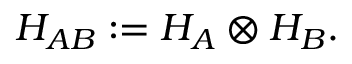Convert formula to latex. <formula><loc_0><loc_0><loc_500><loc_500>H _ { A B } \colon = H _ { A } \otimes H _ { B } .</formula> 